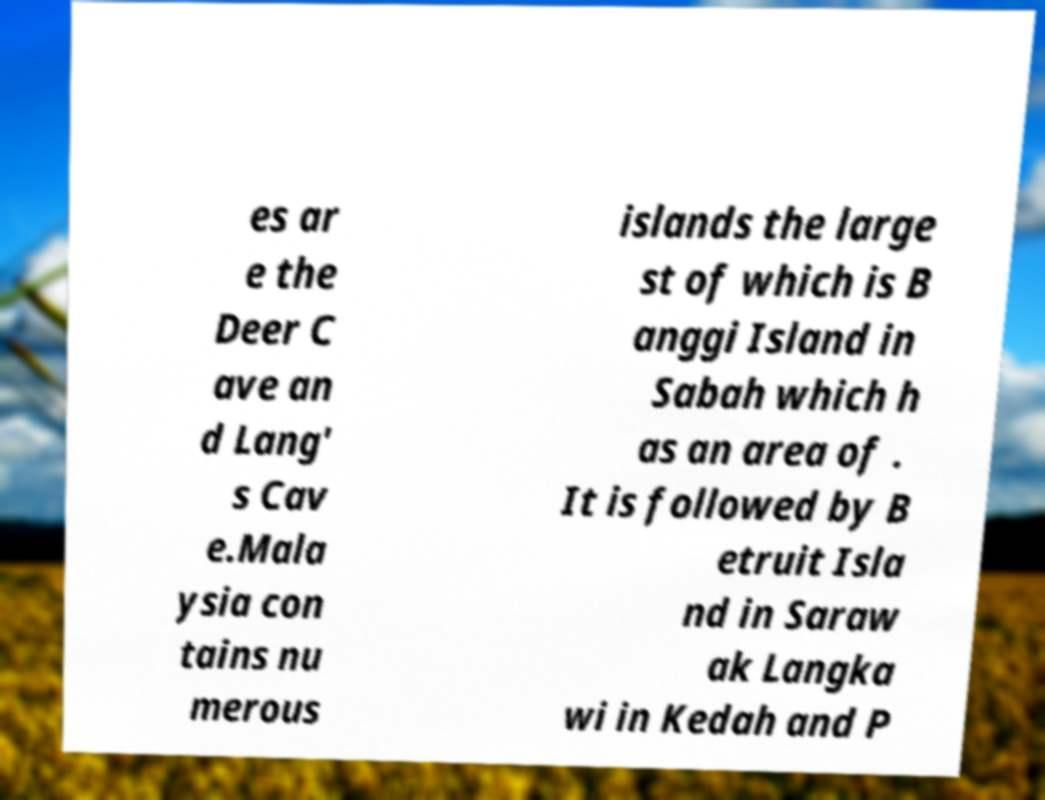Can you read and provide the text displayed in the image?This photo seems to have some interesting text. Can you extract and type it out for me? es ar e the Deer C ave an d Lang' s Cav e.Mala ysia con tains nu merous islands the large st of which is B anggi Island in Sabah which h as an area of . It is followed by B etruit Isla nd in Saraw ak Langka wi in Kedah and P 